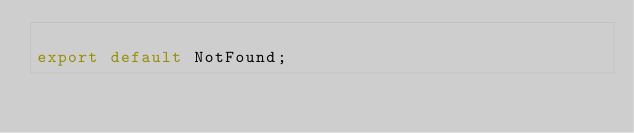Convert code to text. <code><loc_0><loc_0><loc_500><loc_500><_TypeScript_>
export default NotFound;
</code> 